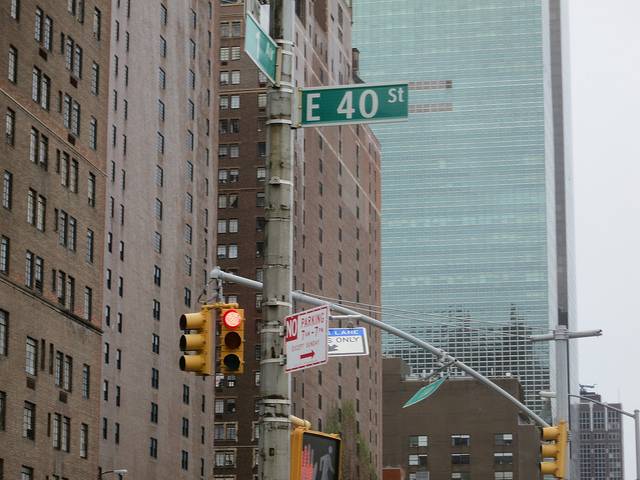Extract all visible text content from this image. E 40 St ONLY 7 7 PARKING NO 